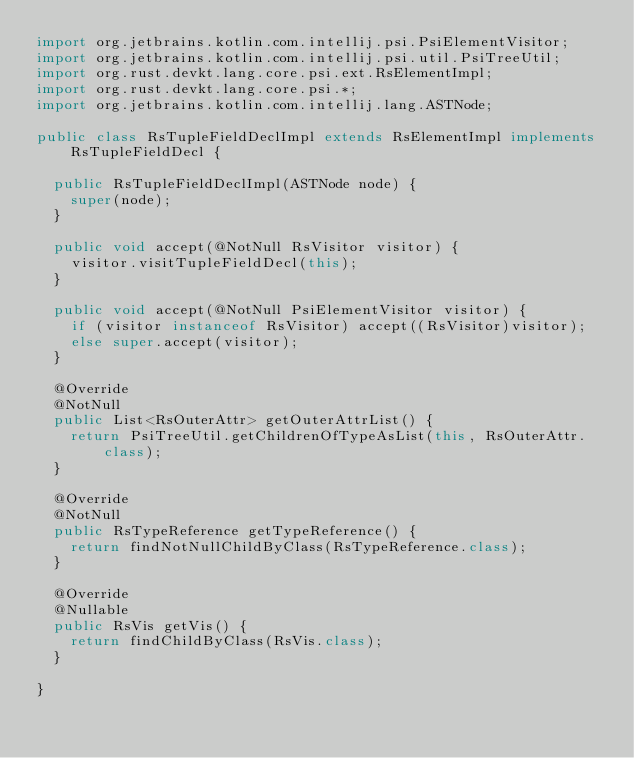Convert code to text. <code><loc_0><loc_0><loc_500><loc_500><_Java_>import org.jetbrains.kotlin.com.intellij.psi.PsiElementVisitor;
import org.jetbrains.kotlin.com.intellij.psi.util.PsiTreeUtil;
import org.rust.devkt.lang.core.psi.ext.RsElementImpl;
import org.rust.devkt.lang.core.psi.*;
import org.jetbrains.kotlin.com.intellij.lang.ASTNode;

public class RsTupleFieldDeclImpl extends RsElementImpl implements RsTupleFieldDecl {

  public RsTupleFieldDeclImpl(ASTNode node) {
    super(node);
  }

  public void accept(@NotNull RsVisitor visitor) {
    visitor.visitTupleFieldDecl(this);
  }

  public void accept(@NotNull PsiElementVisitor visitor) {
    if (visitor instanceof RsVisitor) accept((RsVisitor)visitor);
    else super.accept(visitor);
  }

  @Override
  @NotNull
  public List<RsOuterAttr> getOuterAttrList() {
    return PsiTreeUtil.getChildrenOfTypeAsList(this, RsOuterAttr.class);
  }

  @Override
  @NotNull
  public RsTypeReference getTypeReference() {
    return findNotNullChildByClass(RsTypeReference.class);
  }

  @Override
  @Nullable
  public RsVis getVis() {
    return findChildByClass(RsVis.class);
  }

}
</code> 